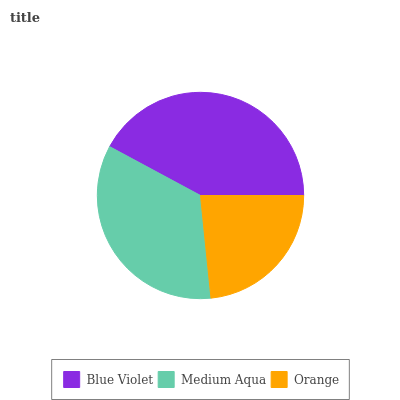Is Orange the minimum?
Answer yes or no. Yes. Is Blue Violet the maximum?
Answer yes or no. Yes. Is Medium Aqua the minimum?
Answer yes or no. No. Is Medium Aqua the maximum?
Answer yes or no. No. Is Blue Violet greater than Medium Aqua?
Answer yes or no. Yes. Is Medium Aqua less than Blue Violet?
Answer yes or no. Yes. Is Medium Aqua greater than Blue Violet?
Answer yes or no. No. Is Blue Violet less than Medium Aqua?
Answer yes or no. No. Is Medium Aqua the high median?
Answer yes or no. Yes. Is Medium Aqua the low median?
Answer yes or no. Yes. Is Blue Violet the high median?
Answer yes or no. No. Is Blue Violet the low median?
Answer yes or no. No. 